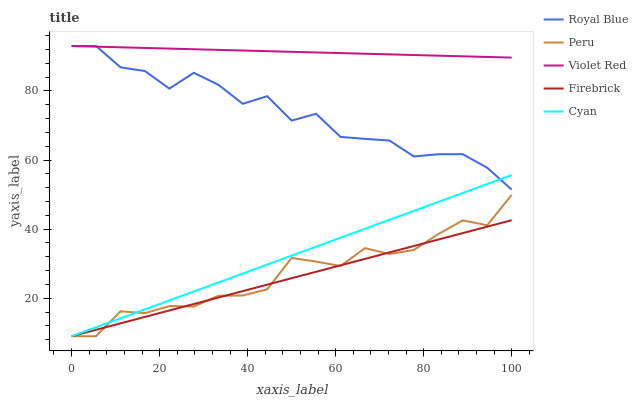Does Firebrick have the minimum area under the curve?
Answer yes or no. Yes. Does Violet Red have the maximum area under the curve?
Answer yes or no. Yes. Does Violet Red have the minimum area under the curve?
Answer yes or no. No. Does Firebrick have the maximum area under the curve?
Answer yes or no. No. Is Violet Red the smoothest?
Answer yes or no. Yes. Is Royal Blue the roughest?
Answer yes or no. Yes. Is Firebrick the smoothest?
Answer yes or no. No. Is Firebrick the roughest?
Answer yes or no. No. Does Firebrick have the lowest value?
Answer yes or no. Yes. Does Violet Red have the lowest value?
Answer yes or no. No. Does Violet Red have the highest value?
Answer yes or no. Yes. Does Firebrick have the highest value?
Answer yes or no. No. Is Firebrick less than Royal Blue?
Answer yes or no. Yes. Is Violet Red greater than Firebrick?
Answer yes or no. Yes. Does Royal Blue intersect Cyan?
Answer yes or no. Yes. Is Royal Blue less than Cyan?
Answer yes or no. No. Is Royal Blue greater than Cyan?
Answer yes or no. No. Does Firebrick intersect Royal Blue?
Answer yes or no. No. 